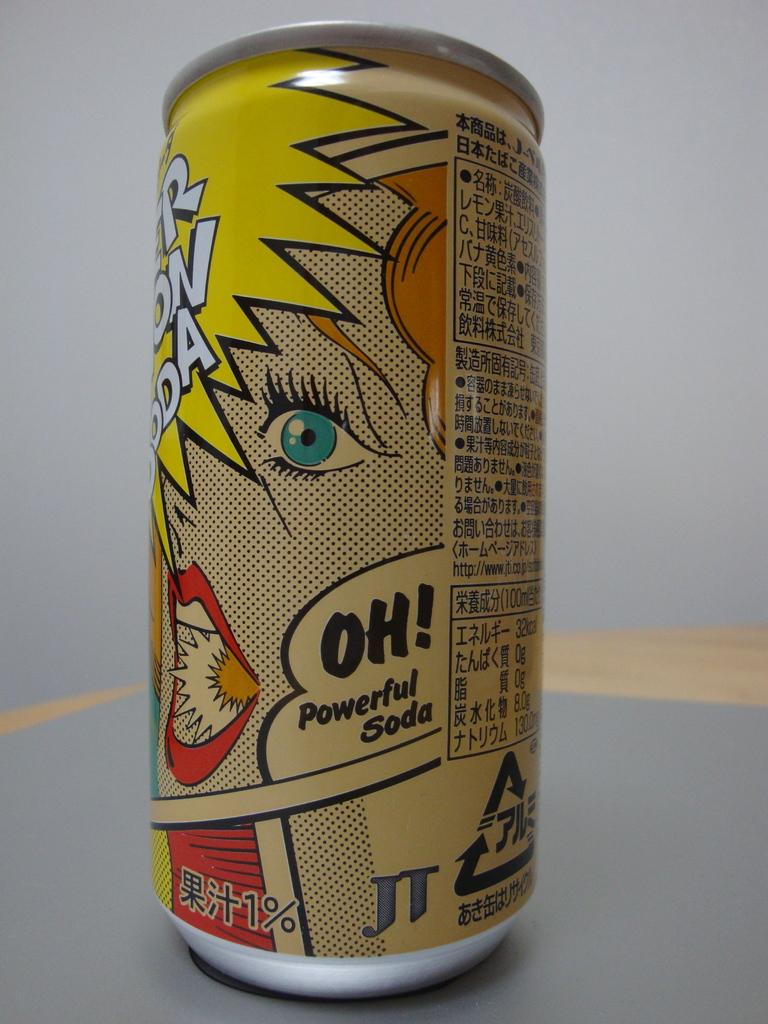Provide a one-sentence caption for the provided image. the word oh is on a can on a gray surface. 